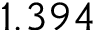<formula> <loc_0><loc_0><loc_500><loc_500>1 . 3 9 4</formula> 